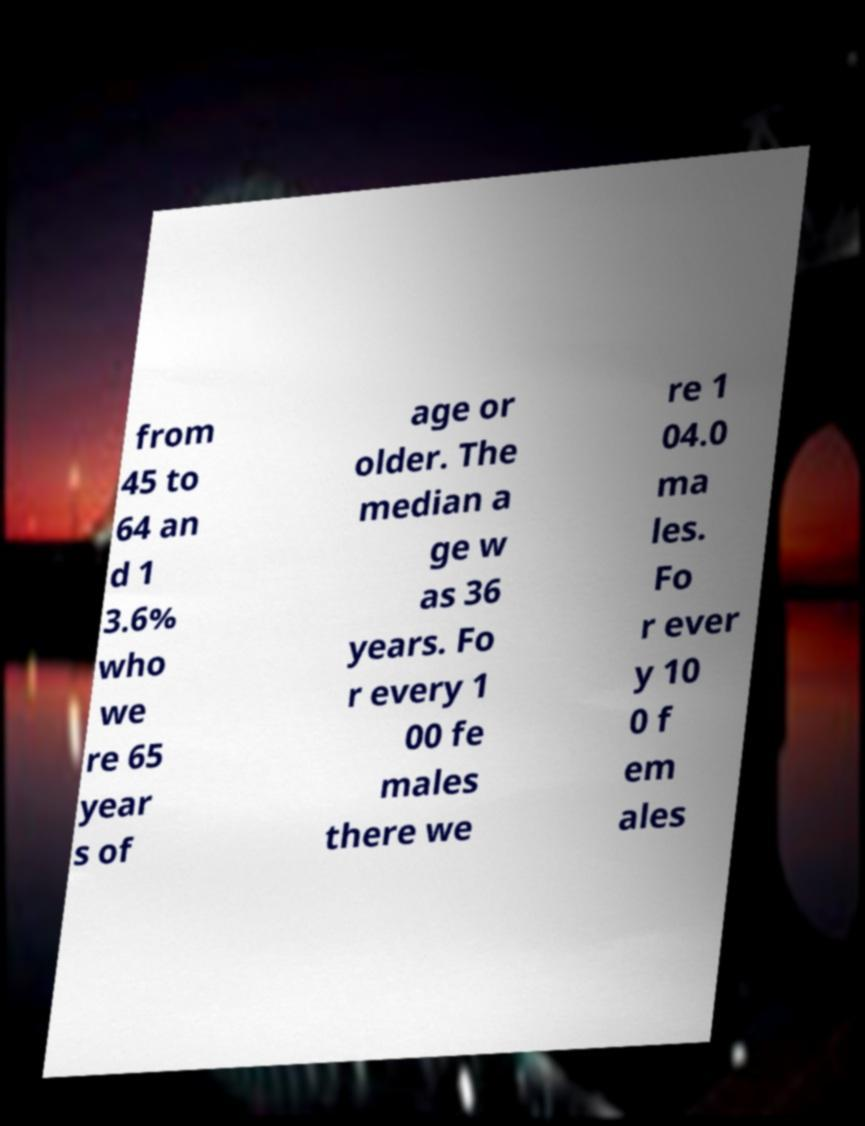Could you extract and type out the text from this image? from 45 to 64 an d 1 3.6% who we re 65 year s of age or older. The median a ge w as 36 years. Fo r every 1 00 fe males there we re 1 04.0 ma les. Fo r ever y 10 0 f em ales 